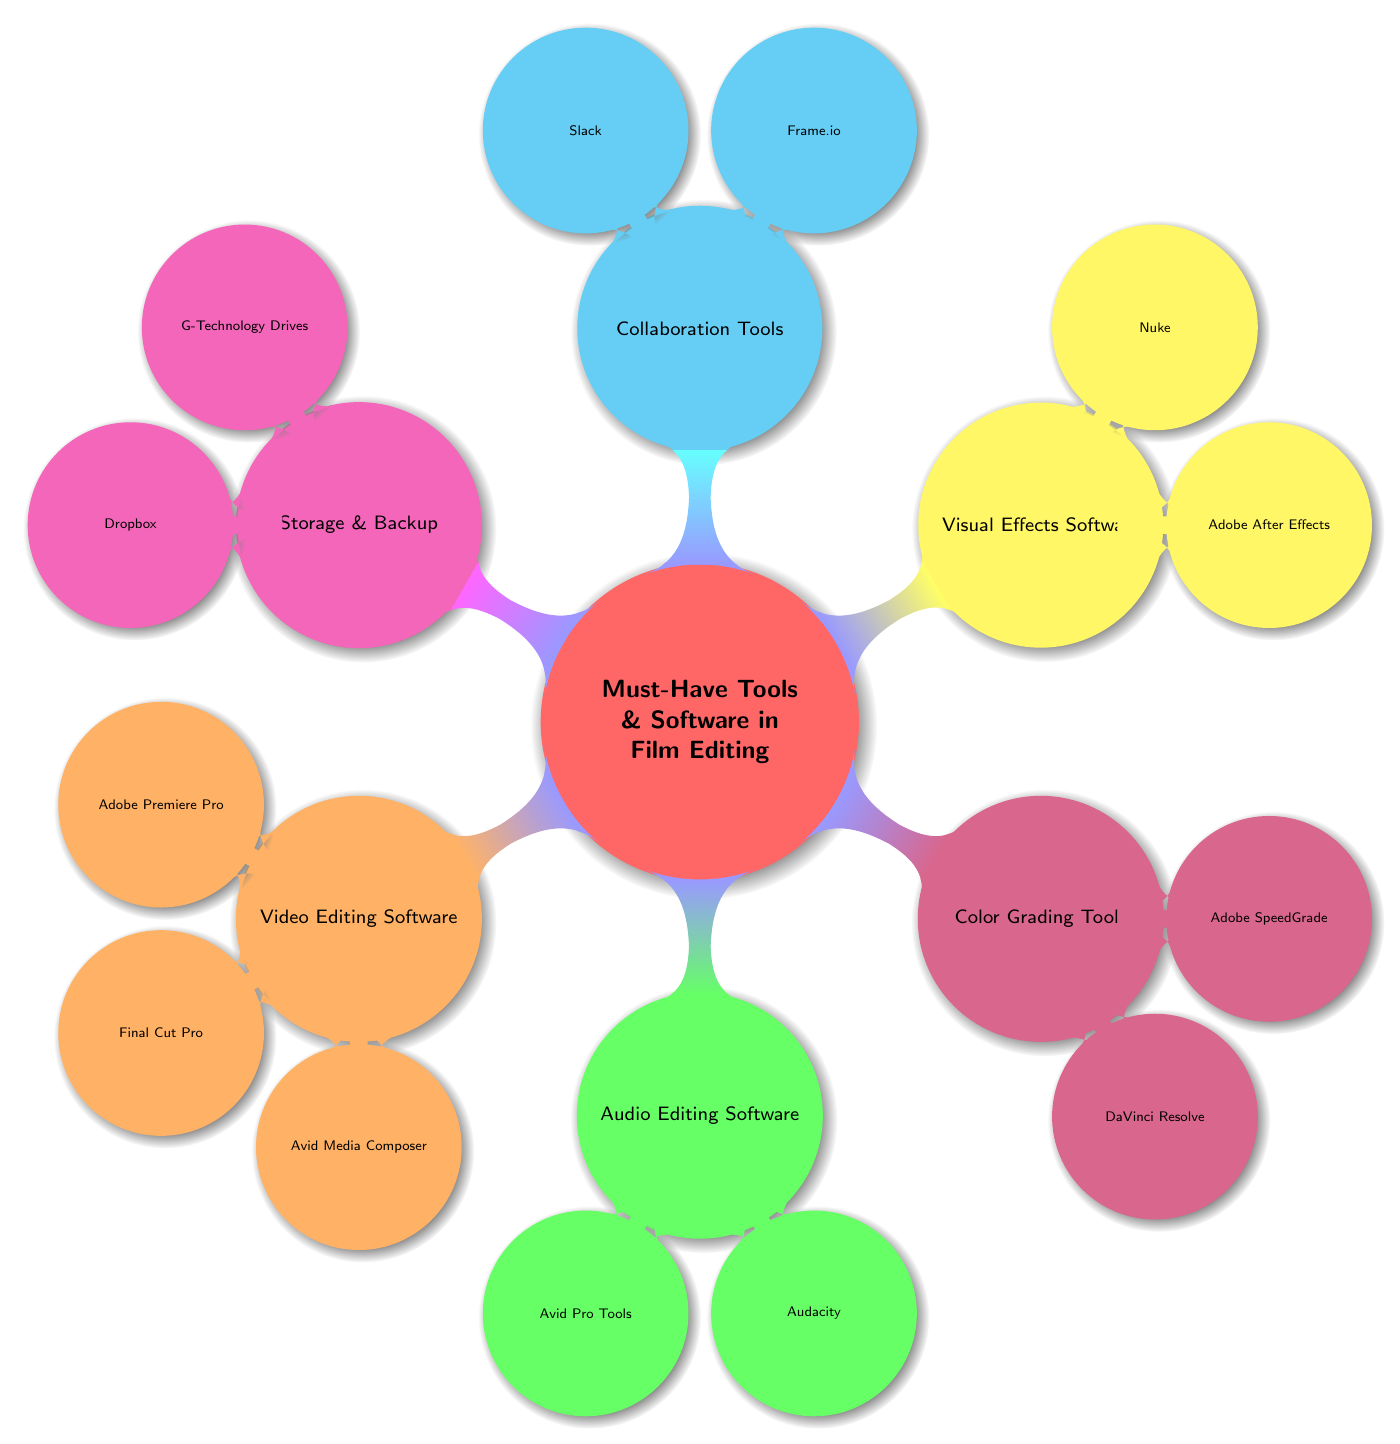What are the main categories of tools and software in film editing? The diagram clearly indicates six main categories: Video Editing Software, Audio Editing Software, Color Grading Tools, Visual Effects Software, Collaboration Tools, and Storage & Backup.
Answer: Six Which software is known as the industry standard in film and TV? Within the Video Editing Software section, Avid Media Composer is specified as the industry standard used in film and TV.
Answer: Avid Media Composer How many audio editing software tools are listed in the diagram? Under the Audio Editing Software category, there are two tools mentioned: Avid Pro Tools and Audacity, thus indicating the total count is two.
Answer: Two What is the cloud-based platform mentioned for collaboration? The Collaboration Tools section includes Frame.io, which is explicitly described as a cloud-based platform for feedback and collaboration.
Answer: Frame.io Which software includes editing, audio post-production, and color correction? DaVinci Resolve, located in the Color Grading Tools section, is described as a comprehensive tool that encompasses editing, audio post-production, and color correction functions.
Answer: DaVinci Resolve What distinguishes Adobe After Effects in the diagram? In the Visual Effects Software category, Adobe After Effects is highlighted as essential for creating visual effects and motion graphics, which sets it apart from other software mentioned.
Answer: Essential for creating visual effects How many tools are available in the Storage & Backup category? The diagram lists two tools under the Storage & Backup section: G-Technology Drives and Dropbox, confirming that the total count is two.
Answer: Two Which audio editing software is open-source? The second tool listed in the Audio Editing Software category is Audacity, explicitly mentioned as open-source software.
Answer: Audacity What is the purpose of Slack according to the diagram? In the Collaboration Tools section, Slack is identified as a popular communication tool for team collaborations and project management.
Answer: Team collaborations and project management 